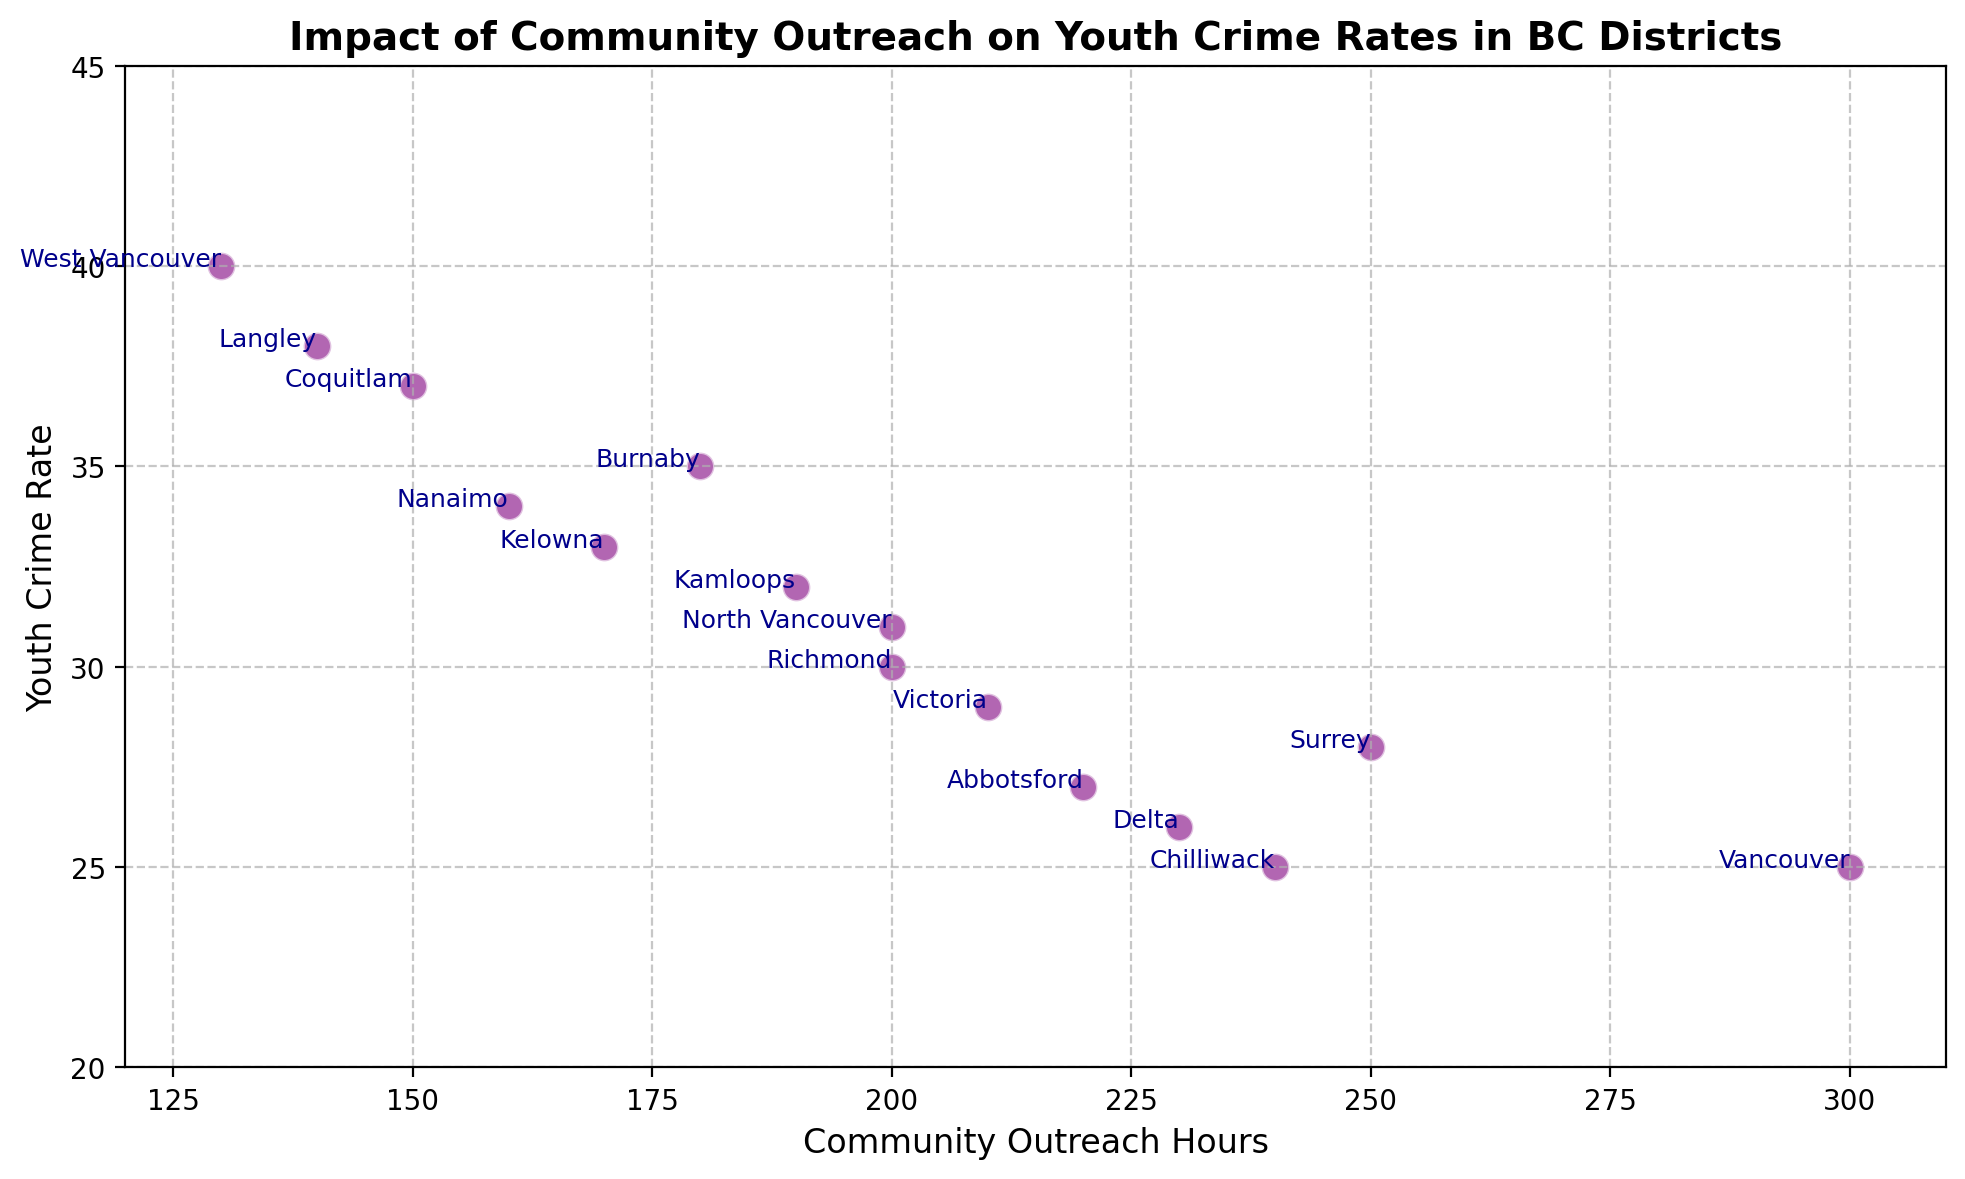What is the youth crime rate in Vancouver? Locate the point that represents Vancouver on the scatter plot. The Y-axis value at this point is the youth crime rate for Vancouver.
Answer: 25 Which district had the highest youth crime rate, and what was it? Look for the highest point on the Y-axis (Youth Crime Rate) on the scatter plot and check the district label associated with it.
Answer: West Vancouver, 40 How does the youth crime rate in Richmond compare to that in Surrey? Find the points representing Richmond and Surrey on the scatter plot. Compare their Y-axis values (Youth Crime Rates). Richmond has a crime rate of 30, while Surrey has 28. Richmond's rate is higher.
Answer: Richmond has a higher youth crime rate Which district invested the fewest hours in community outreach, and what was the corresponding youth crime rate? Search for the lowest point on the X-axis (Community Outreach Hours) and identify the district label attached. Then, check the corresponding Y value (Youth Crime Rate).
Answer: West Vancouver, 40 What is the correlation between Community Outreach hours and Youth Crime Rate? Observe the general trend of points as you move from left to right (increasing outreach hours) on the scatter plot. If the points tend to go downwards, it implies a negative correlation.
Answer: Negative correlation What is the difference in community outreach hours between the district with the highest youth crime rate and Vancouver? Identify the outreach hours for West Vancouver (130) and Vancouver (300). Subtract the lower value from the higher value: 300 - 130 = 170.
Answer: 170 Which district has close to an average youth crime rate and what is its value? Look for a point whose Y-axis value is around the middle range of the data. The middle range for youth crime rates is approximately 30-35. For example, North Vancouver has a crime rate of 31, which is close to the average.
Answer: North Vancouver, 31 How many districts have a youth crime rate of less than 30? Count the number of points on the scatter plot where the Y-axis value is less than 30.
Answer: 7 What can be inferred about the relationship between community outreach hours and youth crime rates in Abbotsford and Chilliwack? Locate Abbotsford and Chilliwack on the scatter plot. Abbotsford has 220 outreach hours and a youth crime rate of 27. Chilliwack has 240 outreach hours and a youth crime rate of 25. Both show a lower crime rate with relatively higher outreach hours, reinforcing the negative correlation.
Answer: Higher outreach, lower crime rate What is the average youth crime rate for districts with over 200 Community Outreach Hours? Identify the districts with outreach hours over 200: Vancouver, Surrey, Abbotsford, Delta, and Chilliwack. Their crime rates are 25, 28, 27, 26, and 25 respectively. Calculate the average: (25+28+27+26+25)/5 = 26.2
Answer: 26.2 